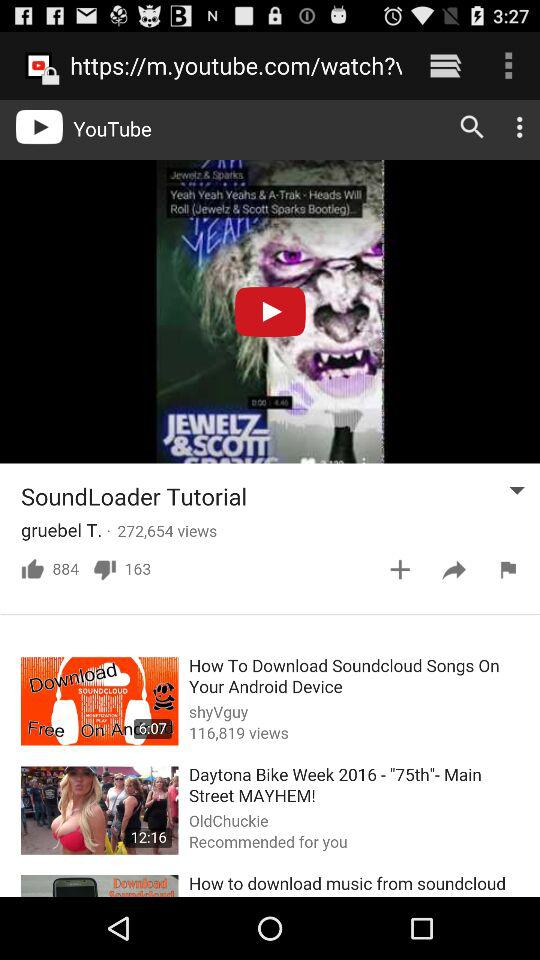What is the number of dislikes on the SoundLoader tutorial? There are 163 dislikes on the SoundLoader tutorial. 